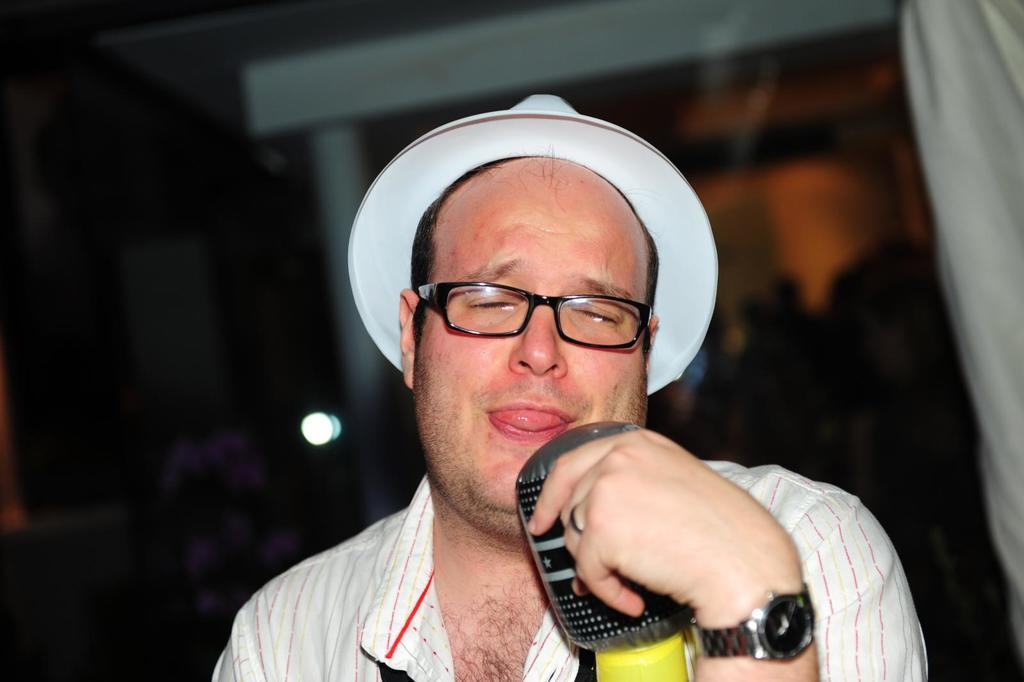What is the main subject of the image? The main subject of the image is a man. What is the man doing in the image? The man is holding an object in his hand. Can you see the man's daughter in the image? There is no mention of a daughter in the image, so it cannot be determined if she is present. 